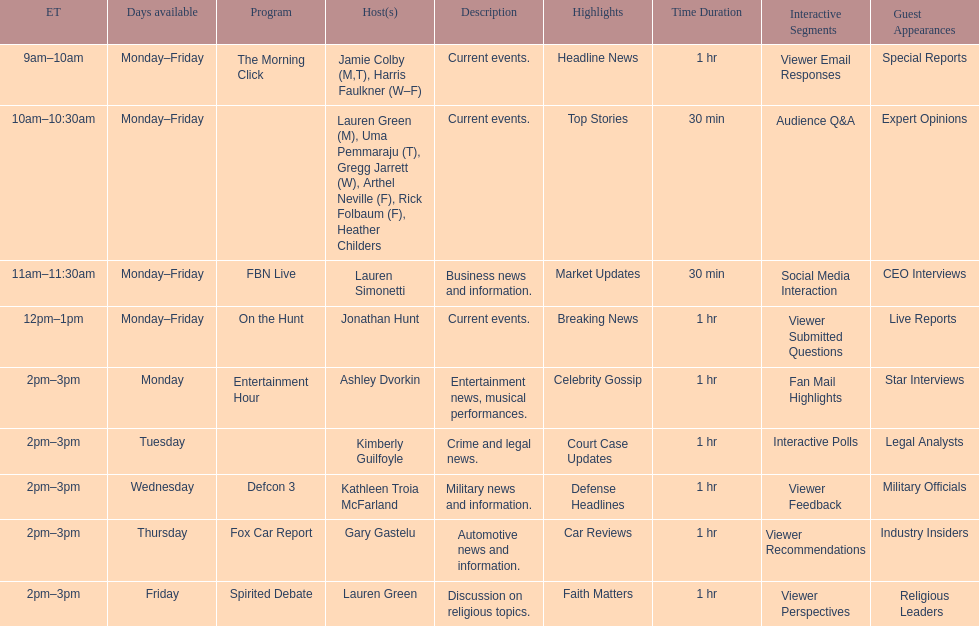What is the number of days per week that the fbn live show is aired? 5. 